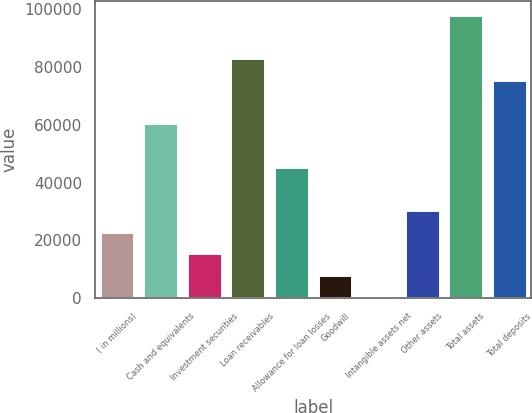Convert chart to OTSL. <chart><loc_0><loc_0><loc_500><loc_500><bar_chart><fcel>( in millions)<fcel>Cash and equivalents<fcel>Investment securities<fcel>Loan receivables<fcel>Allowance for loan losses<fcel>Goodwill<fcel>Intangible assets net<fcel>Other assets<fcel>Total assets<fcel>Total deposits<nl><fcel>23023.5<fcel>60531<fcel>15522<fcel>83035.5<fcel>45528<fcel>8020.5<fcel>519<fcel>30525<fcel>98038.5<fcel>75534<nl></chart> 